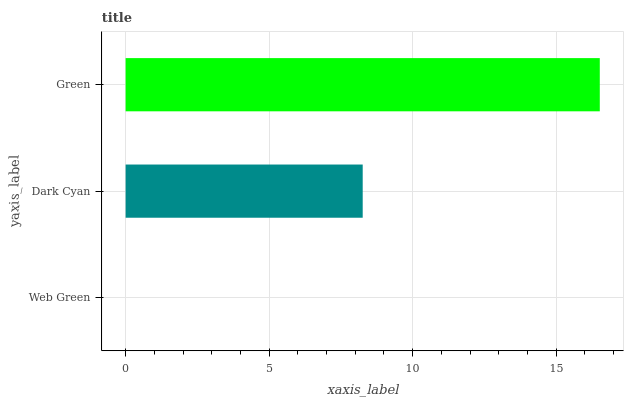Is Web Green the minimum?
Answer yes or no. Yes. Is Green the maximum?
Answer yes or no. Yes. Is Dark Cyan the minimum?
Answer yes or no. No. Is Dark Cyan the maximum?
Answer yes or no. No. Is Dark Cyan greater than Web Green?
Answer yes or no. Yes. Is Web Green less than Dark Cyan?
Answer yes or no. Yes. Is Web Green greater than Dark Cyan?
Answer yes or no. No. Is Dark Cyan less than Web Green?
Answer yes or no. No. Is Dark Cyan the high median?
Answer yes or no. Yes. Is Dark Cyan the low median?
Answer yes or no. Yes. Is Web Green the high median?
Answer yes or no. No. Is Web Green the low median?
Answer yes or no. No. 